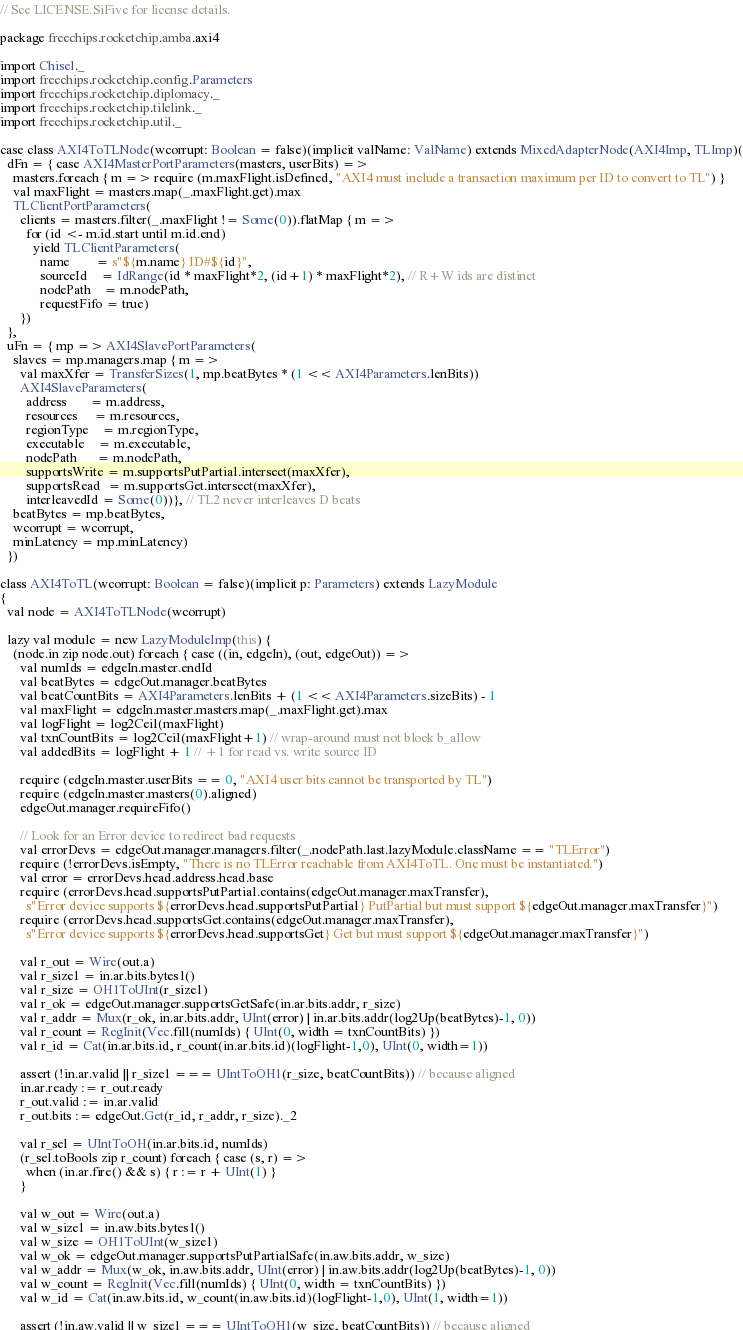Convert code to text. <code><loc_0><loc_0><loc_500><loc_500><_Scala_>// See LICENSE.SiFive for license details.

package freechips.rocketchip.amba.axi4

import Chisel._
import freechips.rocketchip.config.Parameters
import freechips.rocketchip.diplomacy._
import freechips.rocketchip.tilelink._
import freechips.rocketchip.util._

case class AXI4ToTLNode(wcorrupt: Boolean = false)(implicit valName: ValName) extends MixedAdapterNode(AXI4Imp, TLImp)(
  dFn = { case AXI4MasterPortParameters(masters, userBits) =>
    masters.foreach { m => require (m.maxFlight.isDefined, "AXI4 must include a transaction maximum per ID to convert to TL") }
    val maxFlight = masters.map(_.maxFlight.get).max
    TLClientPortParameters(
      clients = masters.filter(_.maxFlight != Some(0)).flatMap { m =>
        for (id <- m.id.start until m.id.end)
          yield TLClientParameters(
            name        = s"${m.name} ID#${id}",
            sourceId    = IdRange(id * maxFlight*2, (id+1) * maxFlight*2), // R+W ids are distinct
            nodePath    = m.nodePath,
            requestFifo = true)
      })
  },
  uFn = { mp => AXI4SlavePortParameters(
    slaves = mp.managers.map { m =>
      val maxXfer = TransferSizes(1, mp.beatBytes * (1 << AXI4Parameters.lenBits))
      AXI4SlaveParameters(
        address       = m.address,
        resources     = m.resources,
        regionType    = m.regionType,
        executable    = m.executable,
        nodePath      = m.nodePath,
        supportsWrite = m.supportsPutPartial.intersect(maxXfer),
        supportsRead  = m.supportsGet.intersect(maxXfer),
        interleavedId = Some(0))}, // TL2 never interleaves D beats
    beatBytes = mp.beatBytes,
    wcorrupt = wcorrupt,
    minLatency = mp.minLatency)
  })

class AXI4ToTL(wcorrupt: Boolean = false)(implicit p: Parameters) extends LazyModule
{
  val node = AXI4ToTLNode(wcorrupt)

  lazy val module = new LazyModuleImp(this) {
    (node.in zip node.out) foreach { case ((in, edgeIn), (out, edgeOut)) =>
      val numIds = edgeIn.master.endId
      val beatBytes = edgeOut.manager.beatBytes
      val beatCountBits = AXI4Parameters.lenBits + (1 << AXI4Parameters.sizeBits) - 1
      val maxFlight = edgeIn.master.masters.map(_.maxFlight.get).max
      val logFlight = log2Ceil(maxFlight)
      val txnCountBits = log2Ceil(maxFlight+1) // wrap-around must not block b_allow
      val addedBits = logFlight + 1 // +1 for read vs. write source ID

      require (edgeIn.master.userBits == 0, "AXI4 user bits cannot be transported by TL")
      require (edgeIn.master.masters(0).aligned)
      edgeOut.manager.requireFifo()

      // Look for an Error device to redirect bad requests
      val errorDevs = edgeOut.manager.managers.filter(_.nodePath.last.lazyModule.className == "TLError")
      require (!errorDevs.isEmpty, "There is no TLError reachable from AXI4ToTL. One must be instantiated.")
      val error = errorDevs.head.address.head.base
      require (errorDevs.head.supportsPutPartial.contains(edgeOut.manager.maxTransfer),
        s"Error device supports ${errorDevs.head.supportsPutPartial} PutPartial but must support ${edgeOut.manager.maxTransfer}")
      require (errorDevs.head.supportsGet.contains(edgeOut.manager.maxTransfer),
        s"Error device supports ${errorDevs.head.supportsGet} Get but must support ${edgeOut.manager.maxTransfer}")

      val r_out = Wire(out.a)
      val r_size1 = in.ar.bits.bytes1()
      val r_size = OH1ToUInt(r_size1)
      val r_ok = edgeOut.manager.supportsGetSafe(in.ar.bits.addr, r_size)
      val r_addr = Mux(r_ok, in.ar.bits.addr, UInt(error) | in.ar.bits.addr(log2Up(beatBytes)-1, 0))
      val r_count = RegInit(Vec.fill(numIds) { UInt(0, width = txnCountBits) })
      val r_id = Cat(in.ar.bits.id, r_count(in.ar.bits.id)(logFlight-1,0), UInt(0, width=1))

      assert (!in.ar.valid || r_size1 === UIntToOH1(r_size, beatCountBits)) // because aligned
      in.ar.ready := r_out.ready
      r_out.valid := in.ar.valid
      r_out.bits := edgeOut.Get(r_id, r_addr, r_size)._2

      val r_sel = UIntToOH(in.ar.bits.id, numIds)
      (r_sel.toBools zip r_count) foreach { case (s, r) =>
        when (in.ar.fire() && s) { r := r + UInt(1) }
      }

      val w_out = Wire(out.a)
      val w_size1 = in.aw.bits.bytes1()
      val w_size = OH1ToUInt(w_size1)
      val w_ok = edgeOut.manager.supportsPutPartialSafe(in.aw.bits.addr, w_size)
      val w_addr = Mux(w_ok, in.aw.bits.addr, UInt(error) | in.aw.bits.addr(log2Up(beatBytes)-1, 0))
      val w_count = RegInit(Vec.fill(numIds) { UInt(0, width = txnCountBits) })
      val w_id = Cat(in.aw.bits.id, w_count(in.aw.bits.id)(logFlight-1,0), UInt(1, width=1))

      assert (!in.aw.valid || w_size1 === UIntToOH1(w_size, beatCountBits)) // because aligned</code> 